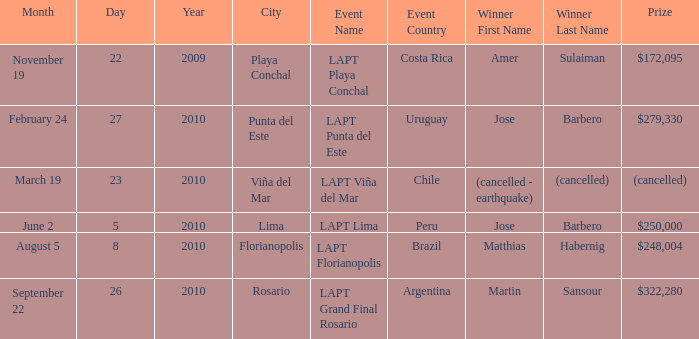What is the date amer sulaiman won? November 19–22, 2009. Help me parse the entirety of this table. {'header': ['Month', 'Day', 'Year', 'City', 'Event Name', 'Event Country', 'Winner First Name', 'Winner Last Name', 'Prize'], 'rows': [['November 19', '22', '2009', 'Playa Conchal', 'LAPT Playa Conchal', 'Costa Rica', 'Amer', 'Sulaiman', '$172,095'], ['February 24', '27', '2010', 'Punta del Este', 'LAPT Punta del Este', 'Uruguay', 'Jose', 'Barbero', '$279,330'], ['March 19', '23', '2010', 'Viña del Mar', 'LAPT Viña del Mar', 'Chile', '(cancelled - earthquake)', '(cancelled)', '(cancelled)'], ['June 2', '5', '2010', 'Lima', 'LAPT Lima', 'Peru', 'Jose', 'Barbero', '$250,000'], ['August 5', '8', '2010', 'Florianopolis', 'LAPT Florianopolis', 'Brazil', 'Matthias', 'Habernig', '$248,004'], ['September 22', '26', '2010', 'Rosario', 'LAPT Grand Final Rosario', 'Argentina', 'Martin', 'Sansour', '$322,280']]} 